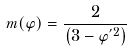Convert formula to latex. <formula><loc_0><loc_0><loc_500><loc_500>m ( \varphi ) = \frac { 2 } { \left ( 3 - \varphi ^ { ^ { \prime } 2 } \right ) }</formula> 